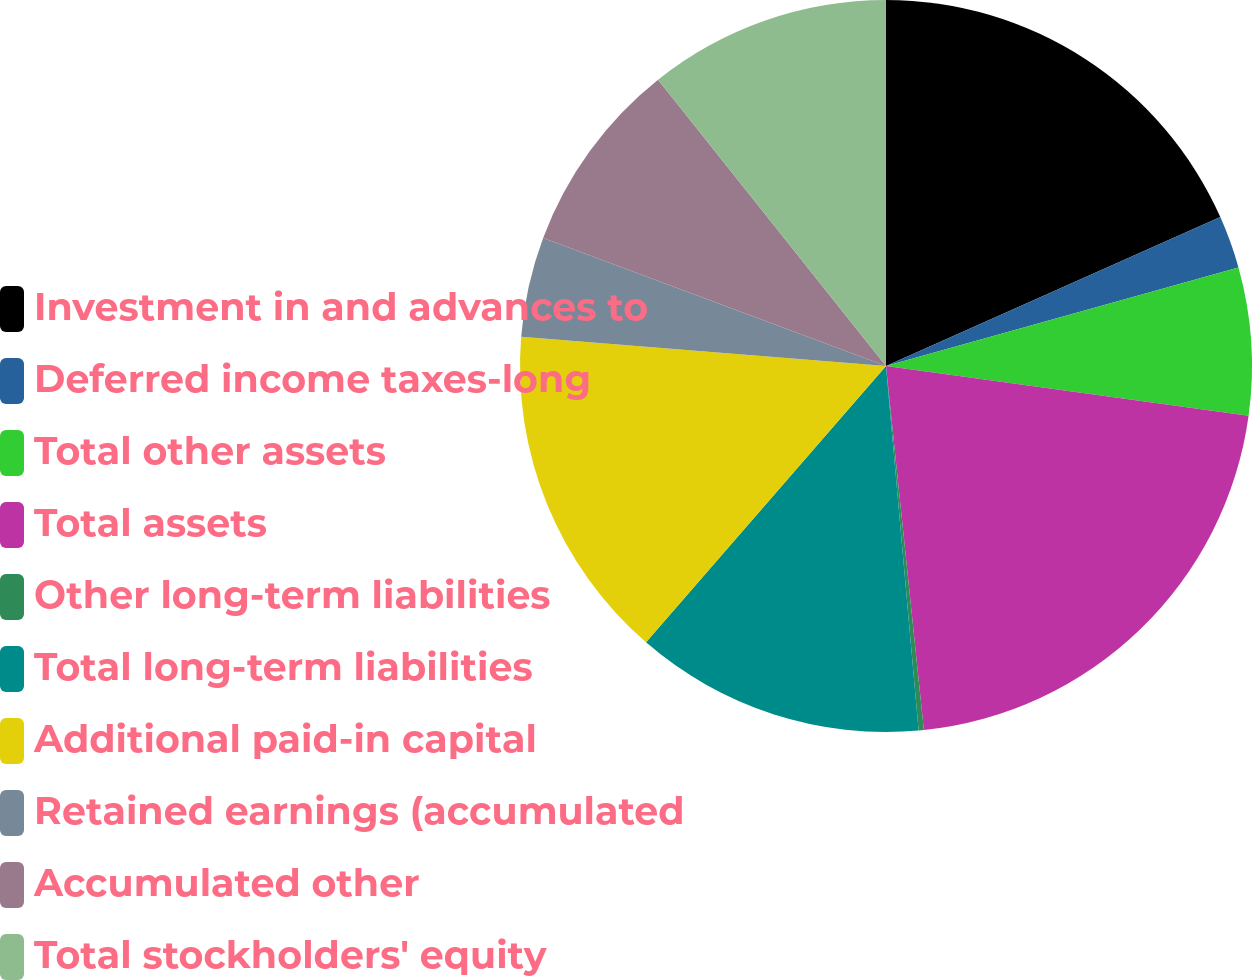Convert chart. <chart><loc_0><loc_0><loc_500><loc_500><pie_chart><fcel>Investment in and advances to<fcel>Deferred income taxes-long<fcel>Total other assets<fcel>Total assets<fcel>Other long-term liabilities<fcel>Total long-term liabilities<fcel>Additional paid-in capital<fcel>Retained earnings (accumulated<fcel>Accumulated other<fcel>Total stockholders' equity<nl><fcel>18.33%<fcel>2.33%<fcel>6.51%<fcel>21.18%<fcel>0.23%<fcel>12.8%<fcel>14.89%<fcel>4.42%<fcel>8.61%<fcel>10.7%<nl></chart> 